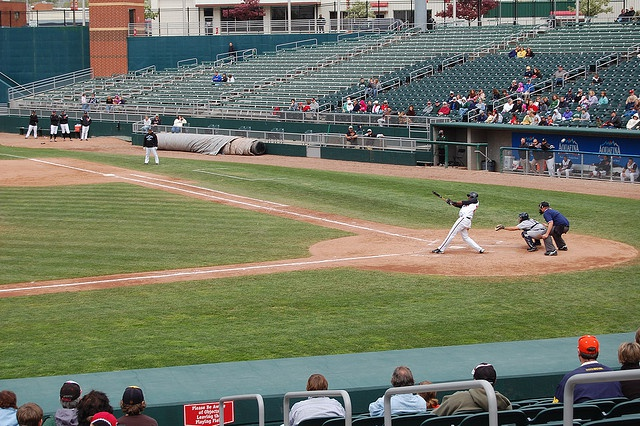Describe the objects in this image and their specific colors. I can see people in gray, black, darkgray, and blue tones, people in gray, navy, black, and red tones, people in gray, black, and darkgray tones, people in gray, lightgray, darkgray, and tan tones, and people in gray, black, and maroon tones in this image. 